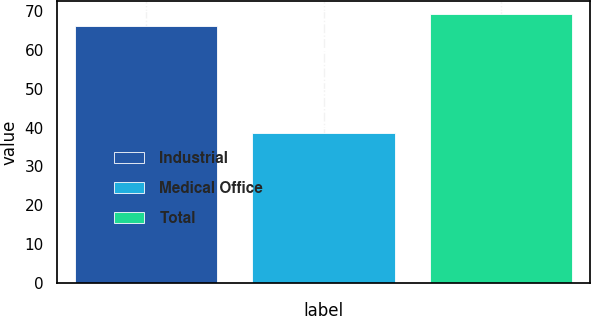<chart> <loc_0><loc_0><loc_500><loc_500><bar_chart><fcel>Industrial<fcel>Medical Office<fcel>Total<nl><fcel>66.2<fcel>38.5<fcel>69.18<nl></chart> 